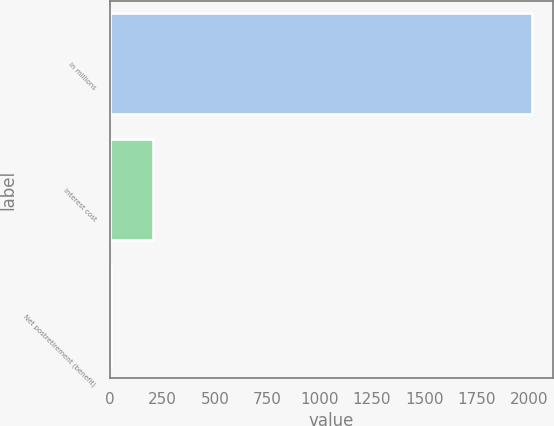Convert chart to OTSL. <chart><loc_0><loc_0><loc_500><loc_500><bar_chart><fcel>In millions<fcel>Interest cost<fcel>Net postretirement (benefit)<nl><fcel>2012<fcel>204.8<fcel>4<nl></chart> 